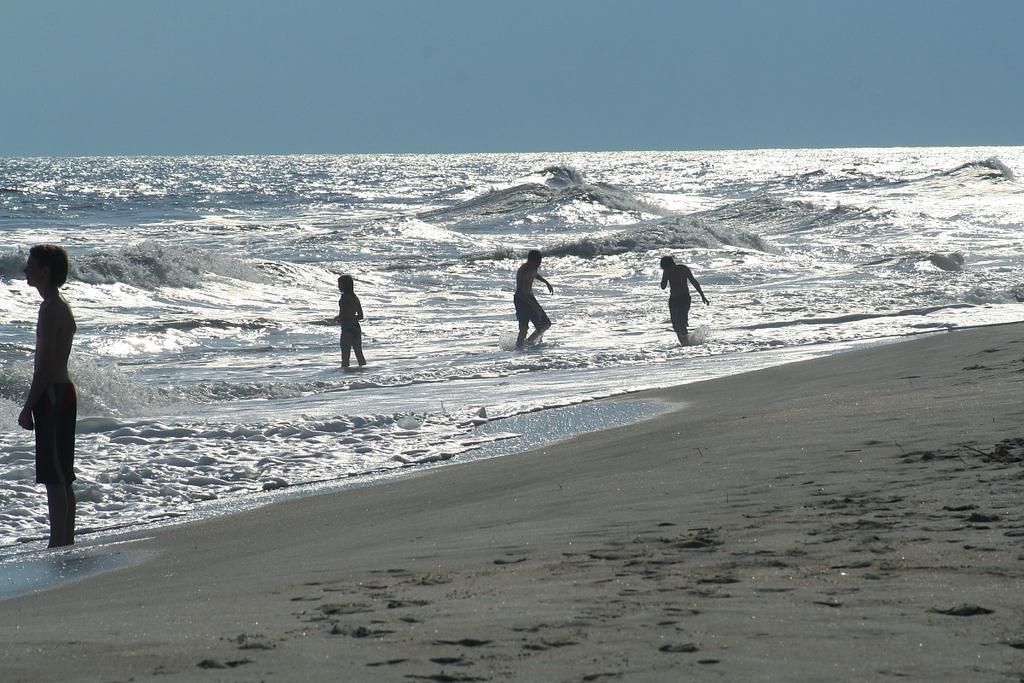Who or what can be seen in the image? There are people in the image. Where are the people located? The people are on the water. What is the nature of the terrain at the bottom of the image? There is a muddy floor at the bottom side of the image. What type of location might this be? The location appears to be a beach. How many quince are visible in the image? There are no quince present in the image. What type of poison can be seen affecting the ants in the image? There are no ants or poison present in the image. 